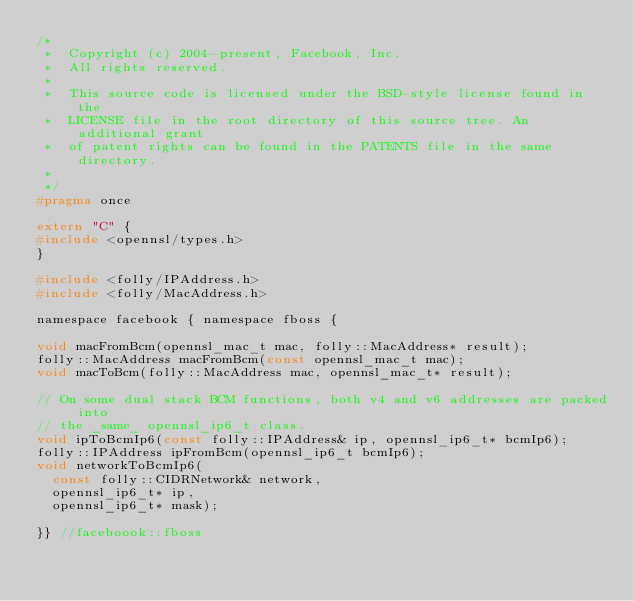<code> <loc_0><loc_0><loc_500><loc_500><_C_>/*
 *  Copyright (c) 2004-present, Facebook, Inc.
 *  All rights reserved.
 *
 *  This source code is licensed under the BSD-style license found in the
 *  LICENSE file in the root directory of this source tree. An additional grant
 *  of patent rights can be found in the PATENTS file in the same directory.
 *
 */
#pragma once

extern "C" {
#include <opennsl/types.h>
}

#include <folly/IPAddress.h>
#include <folly/MacAddress.h>

namespace facebook { namespace fboss {

void macFromBcm(opennsl_mac_t mac, folly::MacAddress* result);
folly::MacAddress macFromBcm(const opennsl_mac_t mac);
void macToBcm(folly::MacAddress mac, opennsl_mac_t* result);

// On some dual stack BCM functions, both v4 and v6 addresses are packed into
// the _same_ opennsl_ip6_t class.
void ipToBcmIp6(const folly::IPAddress& ip, opennsl_ip6_t* bcmIp6);
folly::IPAddress ipFromBcm(opennsl_ip6_t bcmIp6);
void networkToBcmIp6(
  const folly::CIDRNetwork& network,
  opennsl_ip6_t* ip,
  opennsl_ip6_t* mask);

}} //faceboook::fboss
</code> 